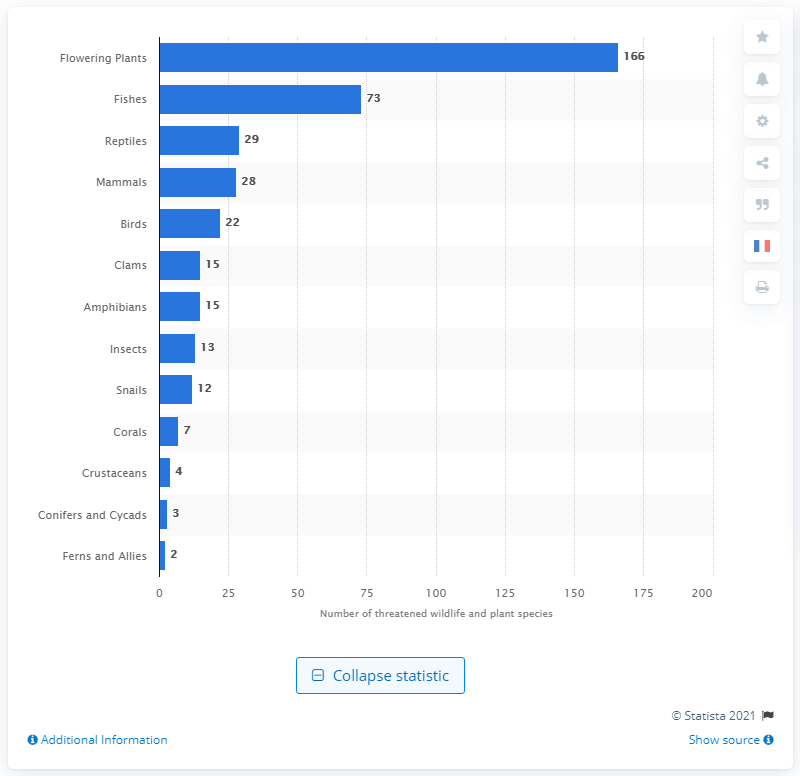Give some essential details in this illustration. It is estimated that 13 insect species are likely to become endangered in the near future due to various human activities and environmental factors. 